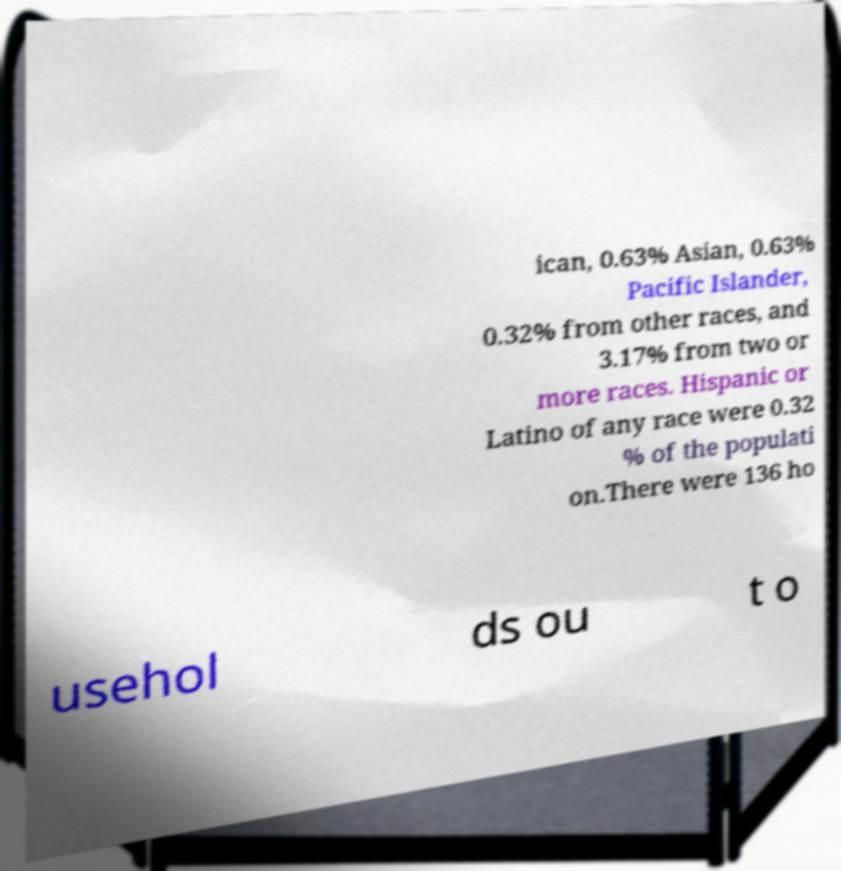I need the written content from this picture converted into text. Can you do that? ican, 0.63% Asian, 0.63% Pacific Islander, 0.32% from other races, and 3.17% from two or more races. Hispanic or Latino of any race were 0.32 % of the populati on.There were 136 ho usehol ds ou t o 